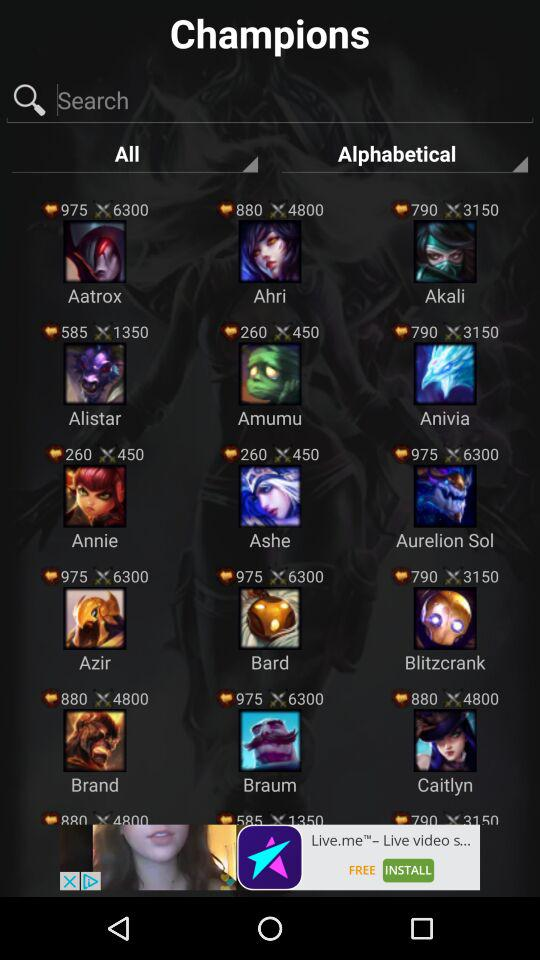What is the application name? The application name is "Champions". 